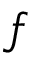<formula> <loc_0><loc_0><loc_500><loc_500>f</formula> 